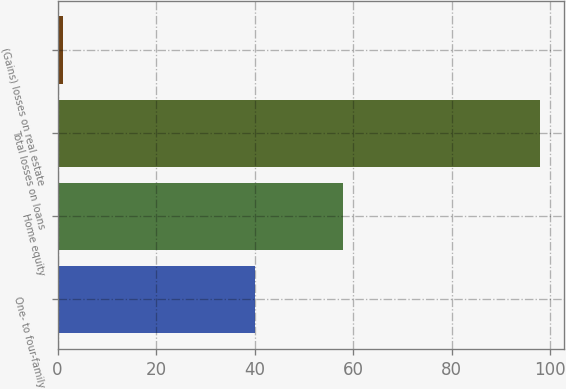<chart> <loc_0><loc_0><loc_500><loc_500><bar_chart><fcel>One- to four-family<fcel>Home equity<fcel>Total losses on loans<fcel>(Gains) losses on real estate<nl><fcel>40<fcel>58<fcel>98<fcel>1<nl></chart> 